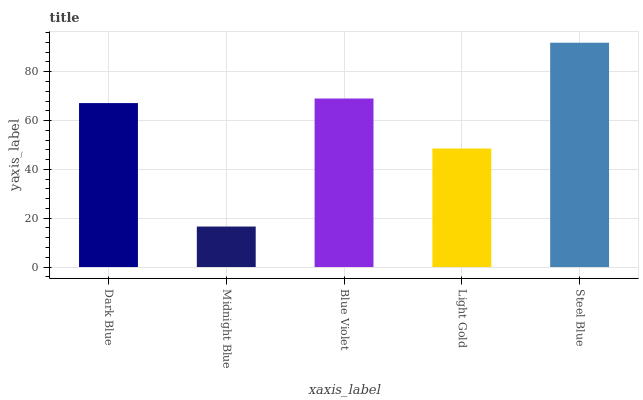Is Midnight Blue the minimum?
Answer yes or no. Yes. Is Steel Blue the maximum?
Answer yes or no. Yes. Is Blue Violet the minimum?
Answer yes or no. No. Is Blue Violet the maximum?
Answer yes or no. No. Is Blue Violet greater than Midnight Blue?
Answer yes or no. Yes. Is Midnight Blue less than Blue Violet?
Answer yes or no. Yes. Is Midnight Blue greater than Blue Violet?
Answer yes or no. No. Is Blue Violet less than Midnight Blue?
Answer yes or no. No. Is Dark Blue the high median?
Answer yes or no. Yes. Is Dark Blue the low median?
Answer yes or no. Yes. Is Light Gold the high median?
Answer yes or no. No. Is Midnight Blue the low median?
Answer yes or no. No. 